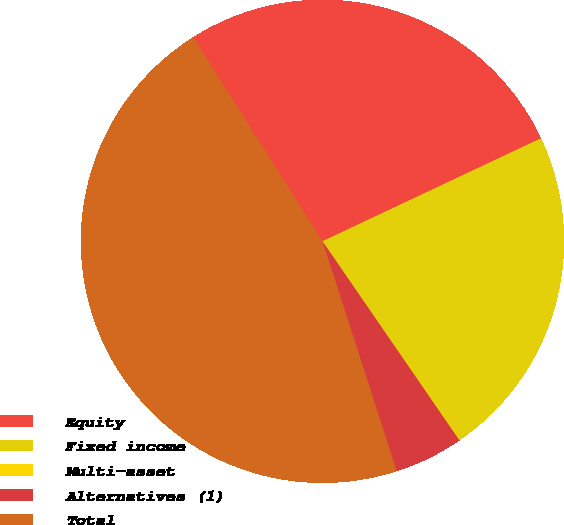Convert chart to OTSL. <chart><loc_0><loc_0><loc_500><loc_500><pie_chart><fcel>Equity<fcel>Fixed income<fcel>Multi-asset<fcel>Alternatives (1)<fcel>Total<nl><fcel>26.98%<fcel>22.39%<fcel>0.03%<fcel>4.62%<fcel>45.98%<nl></chart> 